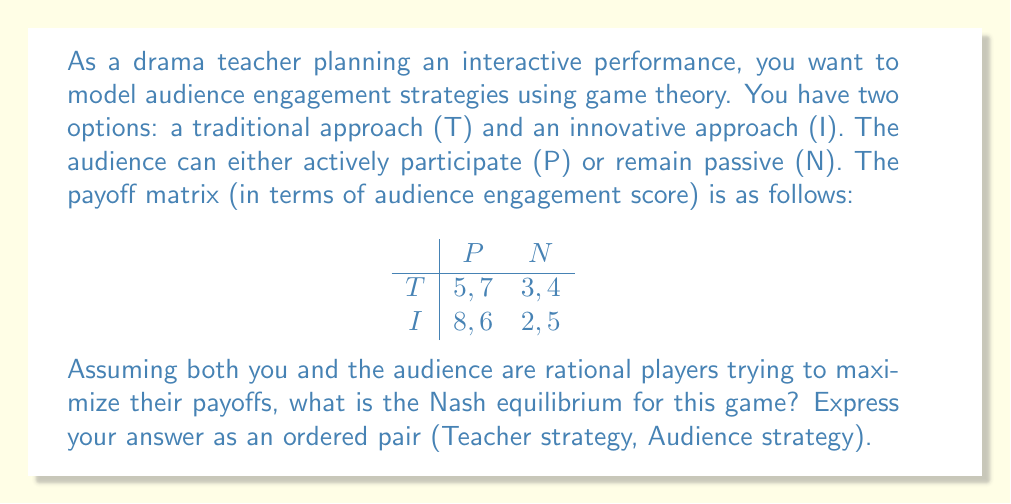Can you answer this question? To find the Nash equilibrium, we need to analyze the best responses for each player:

1. Teacher's perspective:
   - If audience chooses P: I (8) > T (5)
   - If audience chooses N: T (3) > I (2)

2. Audience's perspective:
   - If teacher chooses T: P (7) > N (4)
   - If teacher chooses I: N (5) < P (6)

To find the Nash equilibrium, we look for a strategy combination where neither player has an incentive to unilaterally change their strategy.

Let's examine each possible combination:
1. (T, P): Teacher would switch to I
2. (T, N): Audience would switch to P
3. (I, P): Neither player would switch
4. (I, N): Teacher would switch to T

Therefore, the Nash equilibrium is (I, P), where the teacher chooses the innovative approach and the audience actively participates.

This outcome reflects a scenario where the innovative approach encourages active participation, leading to higher engagement scores for both the teacher and the audience.
Answer: (I, P) 